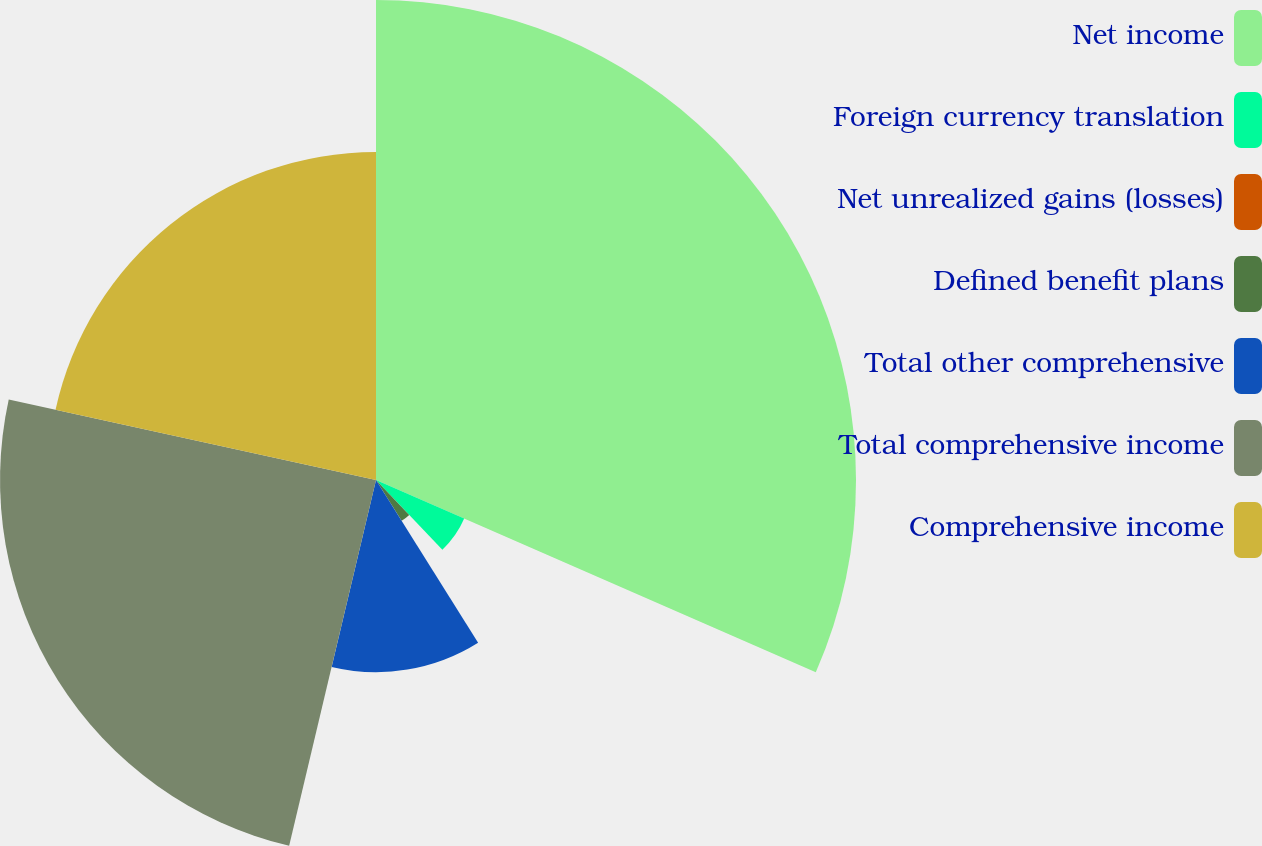Convert chart to OTSL. <chart><loc_0><loc_0><loc_500><loc_500><pie_chart><fcel>Net income<fcel>Foreign currency translation<fcel>Net unrealized gains (losses)<fcel>Defined benefit plans<fcel>Total other comprehensive<fcel>Total comprehensive income<fcel>Comprehensive income<nl><fcel>31.56%<fcel>6.33%<fcel>0.02%<fcel>3.17%<fcel>12.63%<fcel>24.72%<fcel>21.57%<nl></chart> 